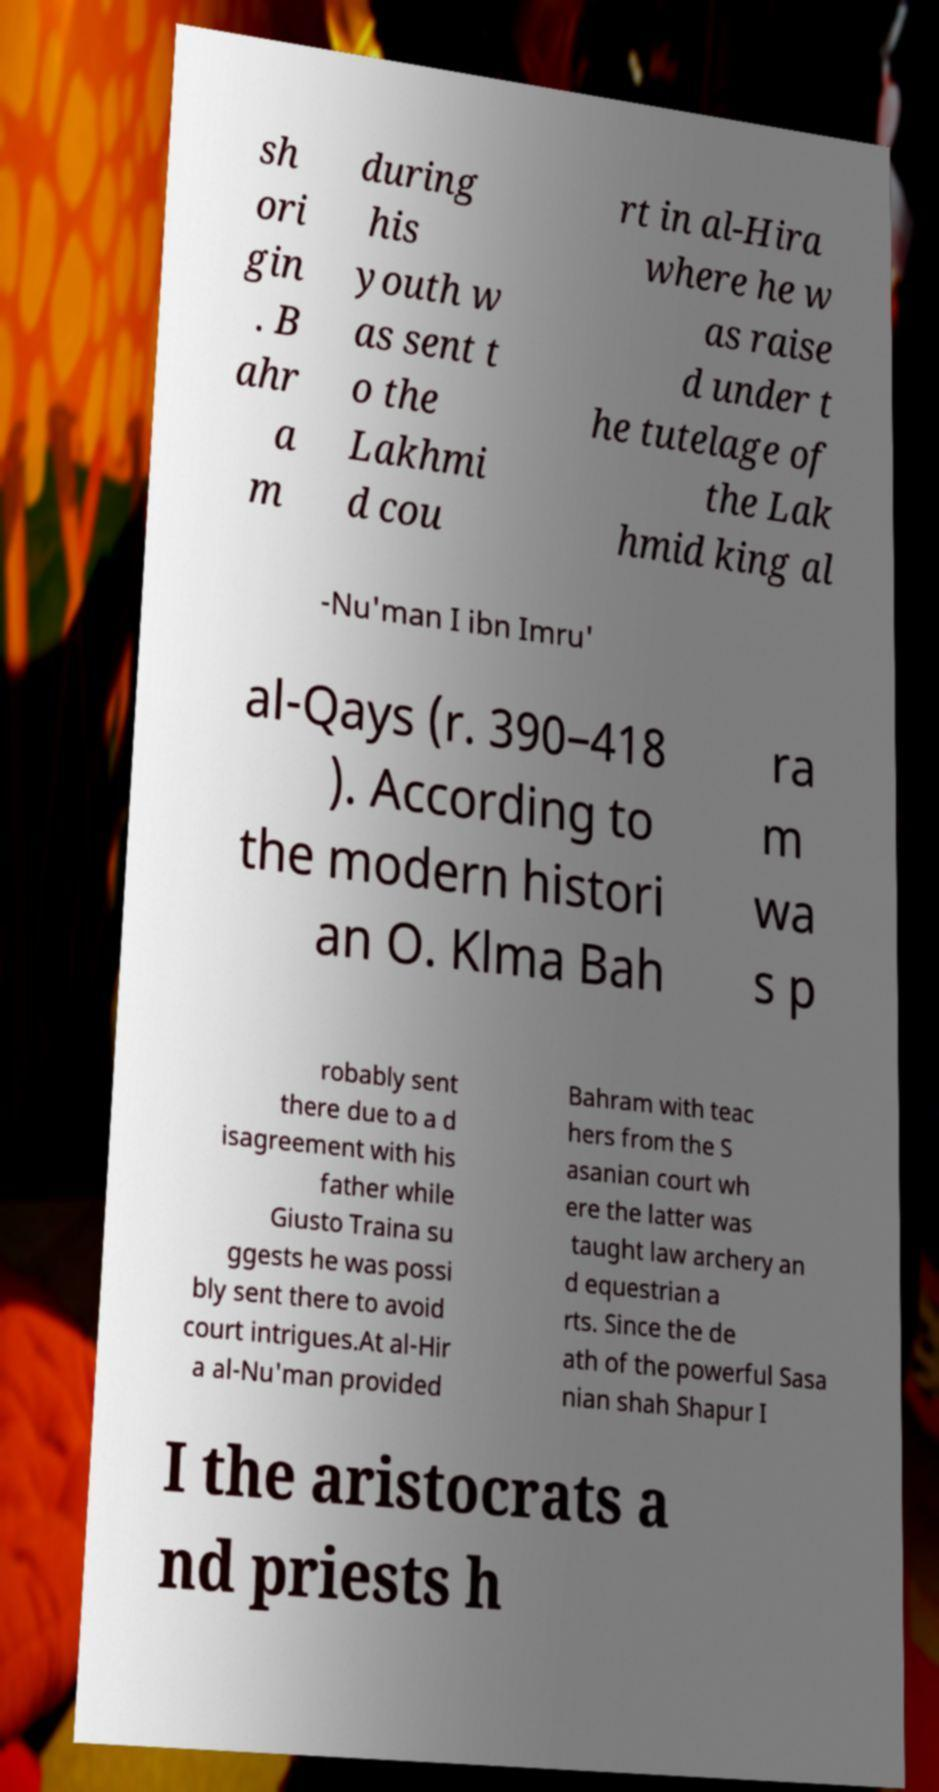What messages or text are displayed in this image? I need them in a readable, typed format. sh ori gin . B ahr a m during his youth w as sent t o the Lakhmi d cou rt in al-Hira where he w as raise d under t he tutelage of the Lak hmid king al -Nu'man I ibn Imru' al-Qays (r. 390–418 ). According to the modern histori an O. Klma Bah ra m wa s p robably sent there due to a d isagreement with his father while Giusto Traina su ggests he was possi bly sent there to avoid court intrigues.At al-Hir a al-Nu'man provided Bahram with teac hers from the S asanian court wh ere the latter was taught law archery an d equestrian a rts. Since the de ath of the powerful Sasa nian shah Shapur I I the aristocrats a nd priests h 